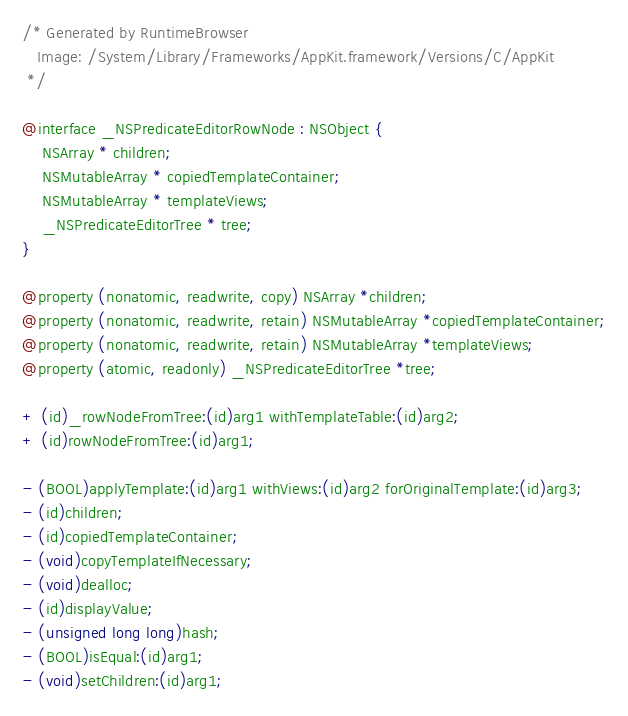<code> <loc_0><loc_0><loc_500><loc_500><_C_>/* Generated by RuntimeBrowser
   Image: /System/Library/Frameworks/AppKit.framework/Versions/C/AppKit
 */

@interface _NSPredicateEditorRowNode : NSObject {
    NSArray * children;
    NSMutableArray * copiedTemplateContainer;
    NSMutableArray * templateViews;
    _NSPredicateEditorTree * tree;
}

@property (nonatomic, readwrite, copy) NSArray *children;
@property (nonatomic, readwrite, retain) NSMutableArray *copiedTemplateContainer;
@property (nonatomic, readwrite, retain) NSMutableArray *templateViews;
@property (atomic, readonly) _NSPredicateEditorTree *tree;

+ (id)_rowNodeFromTree:(id)arg1 withTemplateTable:(id)arg2;
+ (id)rowNodeFromTree:(id)arg1;

- (BOOL)applyTemplate:(id)arg1 withViews:(id)arg2 forOriginalTemplate:(id)arg3;
- (id)children;
- (id)copiedTemplateContainer;
- (void)copyTemplateIfNecessary;
- (void)dealloc;
- (id)displayValue;
- (unsigned long long)hash;
- (BOOL)isEqual:(id)arg1;
- (void)setChildren:(id)arg1;</code> 